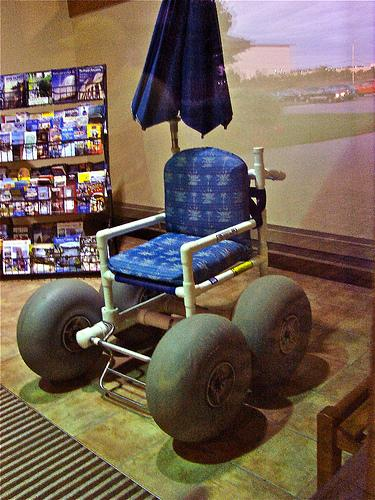What is attached to the chair? Please explain your reasoning. wheels. There are four thick circular objects on the bottom of the chair. 